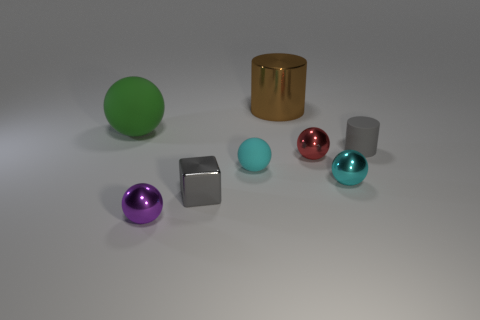Subtract all large rubber balls. How many balls are left? 4 Subtract all green balls. How many balls are left? 4 Subtract 2 balls. How many balls are left? 3 Subtract all red spheres. Subtract all gray blocks. How many spheres are left? 4 Add 1 red balls. How many objects exist? 9 Subtract all blocks. How many objects are left? 7 Subtract 1 brown cylinders. How many objects are left? 7 Subtract all small gray objects. Subtract all gray metallic things. How many objects are left? 5 Add 6 cyan spheres. How many cyan spheres are left? 8 Add 6 large spheres. How many large spheres exist? 7 